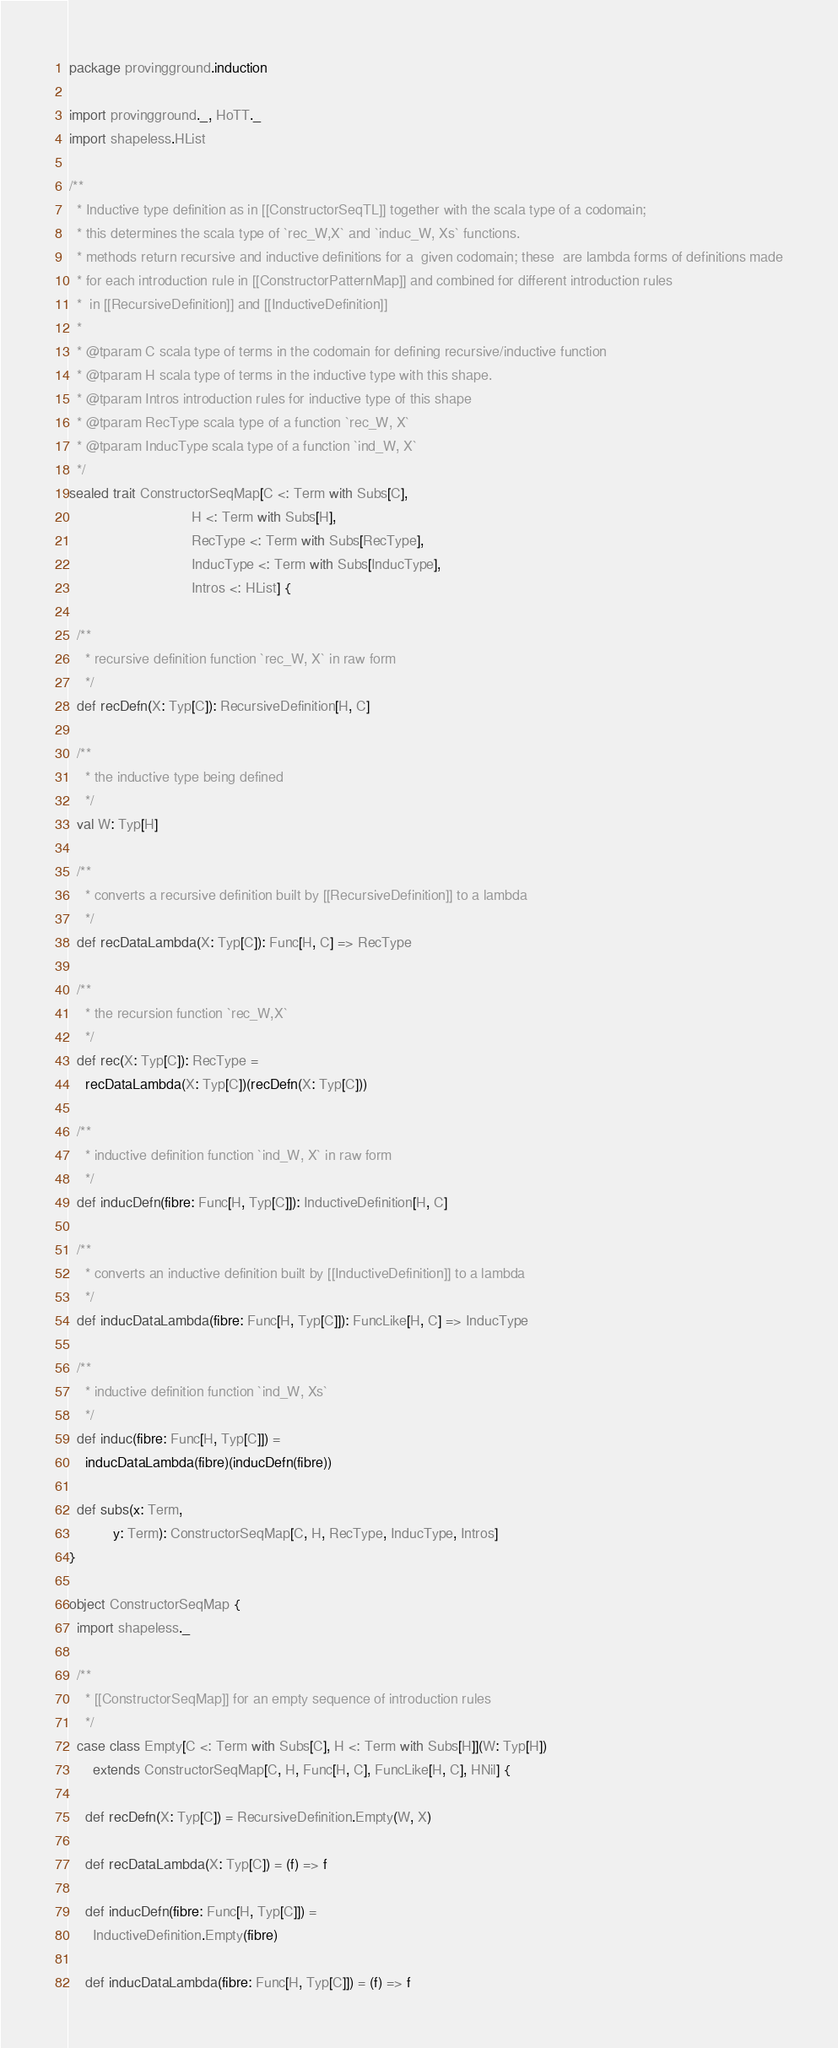Convert code to text. <code><loc_0><loc_0><loc_500><loc_500><_Scala_>package provingground.induction

import provingground._, HoTT._
import shapeless.HList

/**
  * Inductive type definition as in [[ConstructorSeqTL]] together with the scala type of a codomain;
  * this determines the scala type of `rec_W,X` and `induc_W, Xs` functions.
  * methods return recursive and inductive definitions for a  given codomain; these  are lambda forms of definitions made
  * for each introduction rule in [[ConstructorPatternMap]] and combined for different introduction rules
  *  in [[RecursiveDefinition]] and [[InductiveDefinition]]
  *
  * @tparam C scala type of terms in the codomain for defining recursive/inductive function
  * @tparam H scala type of terms in the inductive type with this shape.
  * @tparam Intros introduction rules for inductive type of this shape
  * @tparam RecType scala type of a function `rec_W, X`
  * @tparam InducType scala type of a function `ind_W, X`
  */
sealed trait ConstructorSeqMap[C <: Term with Subs[C],
                               H <: Term with Subs[H],
                               RecType <: Term with Subs[RecType],
                               InducType <: Term with Subs[InducType],
                               Intros <: HList] {

  /**
    * recursive definition function `rec_W, X` in raw form
    */
  def recDefn(X: Typ[C]): RecursiveDefinition[H, C]

  /**
    * the inductive type being defined
    */
  val W: Typ[H]

  /**
    * converts a recursive definition built by [[RecursiveDefinition]] to a lambda
    */
  def recDataLambda(X: Typ[C]): Func[H, C] => RecType

  /**
    * the recursion function `rec_W,X`
    */
  def rec(X: Typ[C]): RecType =
    recDataLambda(X: Typ[C])(recDefn(X: Typ[C]))

  /**
    * inductive definition function `ind_W, X` in raw form
    */
  def inducDefn(fibre: Func[H, Typ[C]]): InductiveDefinition[H, C]

  /**
    * converts an inductive definition built by [[InductiveDefinition]] to a lambda
    */
  def inducDataLambda(fibre: Func[H, Typ[C]]): FuncLike[H, C] => InducType

  /**
    * inductive definition function `ind_W, Xs`
    */
  def induc(fibre: Func[H, Typ[C]]) =
    inducDataLambda(fibre)(inducDefn(fibre))

  def subs(x: Term,
           y: Term): ConstructorSeqMap[C, H, RecType, InducType, Intros]
}

object ConstructorSeqMap {
  import shapeless._

  /**
    * [[ConstructorSeqMap]] for an empty sequence of introduction rules
    */
  case class Empty[C <: Term with Subs[C], H <: Term with Subs[H]](W: Typ[H])
      extends ConstructorSeqMap[C, H, Func[H, C], FuncLike[H, C], HNil] {

    def recDefn(X: Typ[C]) = RecursiveDefinition.Empty(W, X)

    def recDataLambda(X: Typ[C]) = (f) => f

    def inducDefn(fibre: Func[H, Typ[C]]) =
      InductiveDefinition.Empty(fibre)

    def inducDataLambda(fibre: Func[H, Typ[C]]) = (f) => f
</code> 